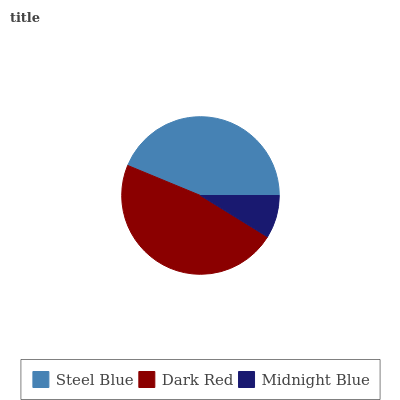Is Midnight Blue the minimum?
Answer yes or no. Yes. Is Dark Red the maximum?
Answer yes or no. Yes. Is Dark Red the minimum?
Answer yes or no. No. Is Midnight Blue the maximum?
Answer yes or no. No. Is Dark Red greater than Midnight Blue?
Answer yes or no. Yes. Is Midnight Blue less than Dark Red?
Answer yes or no. Yes. Is Midnight Blue greater than Dark Red?
Answer yes or no. No. Is Dark Red less than Midnight Blue?
Answer yes or no. No. Is Steel Blue the high median?
Answer yes or no. Yes. Is Steel Blue the low median?
Answer yes or no. Yes. Is Midnight Blue the high median?
Answer yes or no. No. Is Midnight Blue the low median?
Answer yes or no. No. 